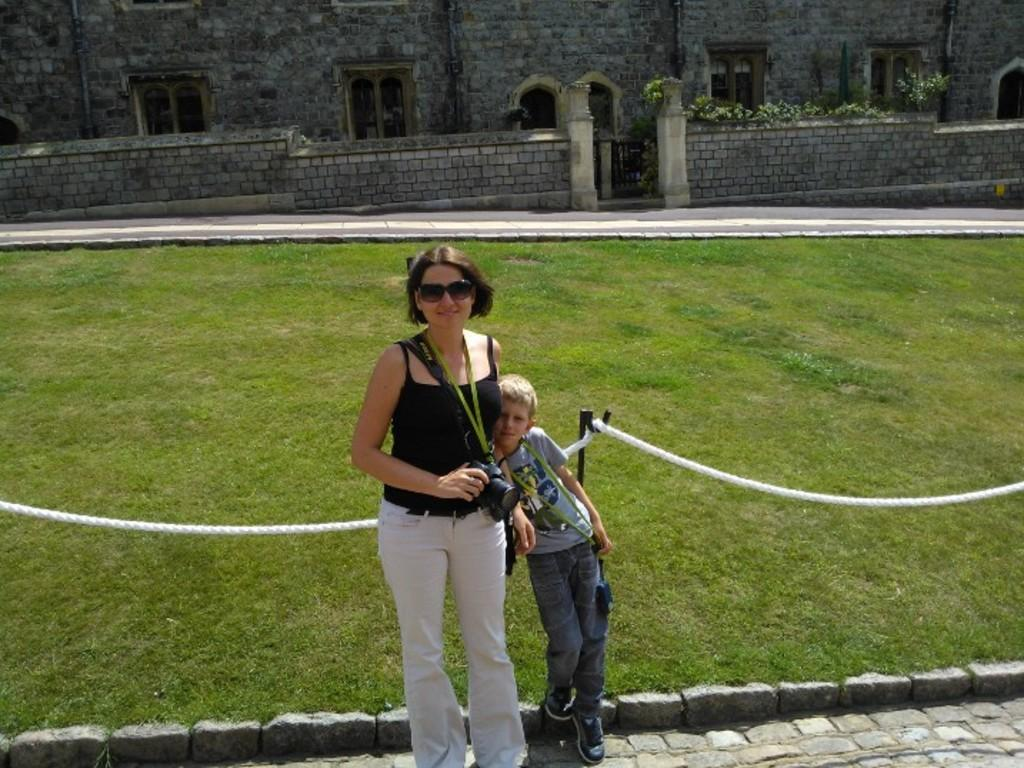Who are the people in the image? There is a woman and a boy in the image. What is the woman holding in the image? The woman is holding a camera in the image. What objects can be seen in the image besides the people? There is a rope, a pole, and grass visible in the image. What can be seen in the background of the image? In the background of the image, there are walls, windows, and plants. How does the image address the issue of pollution? The image does not address the issue of pollution, as it focuses on the woman, the boy, and the objects around them. What type of work is the woman doing in the image? The image does not show the woman working or performing any specific task; she is simply holding a camera. 